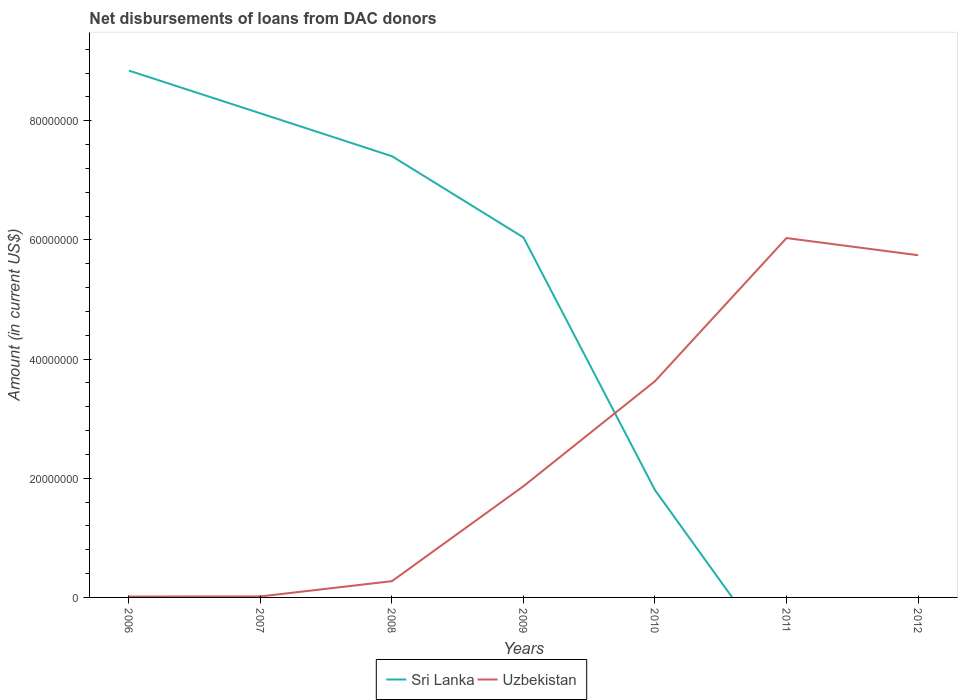Does the line corresponding to Uzbekistan intersect with the line corresponding to Sri Lanka?
Provide a short and direct response. Yes. Is the number of lines equal to the number of legend labels?
Provide a succinct answer. No. Across all years, what is the maximum amount of loans disbursed in Sri Lanka?
Your response must be concise. 0. What is the total amount of loans disbursed in Uzbekistan in the graph?
Ensure brevity in your answer.  -1.59e+07. What is the difference between the highest and the second highest amount of loans disbursed in Uzbekistan?
Provide a short and direct response. 6.02e+07. What is the difference between two consecutive major ticks on the Y-axis?
Make the answer very short. 2.00e+07. Are the values on the major ticks of Y-axis written in scientific E-notation?
Keep it short and to the point. No. Does the graph contain any zero values?
Give a very brief answer. Yes. Does the graph contain grids?
Your answer should be very brief. No. How many legend labels are there?
Offer a terse response. 2. What is the title of the graph?
Your answer should be very brief. Net disbursements of loans from DAC donors. Does "Malawi" appear as one of the legend labels in the graph?
Give a very brief answer. No. What is the label or title of the X-axis?
Ensure brevity in your answer.  Years. What is the Amount (in current US$) of Sri Lanka in 2006?
Give a very brief answer. 8.84e+07. What is the Amount (in current US$) of Uzbekistan in 2006?
Keep it short and to the point. 1.50e+05. What is the Amount (in current US$) in Sri Lanka in 2007?
Provide a succinct answer. 8.13e+07. What is the Amount (in current US$) in Uzbekistan in 2007?
Your answer should be very brief. 1.67e+05. What is the Amount (in current US$) of Sri Lanka in 2008?
Offer a very short reply. 7.41e+07. What is the Amount (in current US$) of Uzbekistan in 2008?
Give a very brief answer. 2.73e+06. What is the Amount (in current US$) of Sri Lanka in 2009?
Offer a terse response. 6.04e+07. What is the Amount (in current US$) of Uzbekistan in 2009?
Make the answer very short. 1.87e+07. What is the Amount (in current US$) in Sri Lanka in 2010?
Make the answer very short. 1.80e+07. What is the Amount (in current US$) of Uzbekistan in 2010?
Offer a terse response. 3.63e+07. What is the Amount (in current US$) of Sri Lanka in 2011?
Offer a terse response. 0. What is the Amount (in current US$) in Uzbekistan in 2011?
Offer a very short reply. 6.03e+07. What is the Amount (in current US$) of Sri Lanka in 2012?
Keep it short and to the point. 0. What is the Amount (in current US$) of Uzbekistan in 2012?
Give a very brief answer. 5.74e+07. Across all years, what is the maximum Amount (in current US$) in Sri Lanka?
Your response must be concise. 8.84e+07. Across all years, what is the maximum Amount (in current US$) in Uzbekistan?
Provide a succinct answer. 6.03e+07. Across all years, what is the minimum Amount (in current US$) in Sri Lanka?
Make the answer very short. 0. What is the total Amount (in current US$) of Sri Lanka in the graph?
Make the answer very short. 3.22e+08. What is the total Amount (in current US$) in Uzbekistan in the graph?
Provide a succinct answer. 1.76e+08. What is the difference between the Amount (in current US$) of Sri Lanka in 2006 and that in 2007?
Offer a terse response. 7.17e+06. What is the difference between the Amount (in current US$) of Uzbekistan in 2006 and that in 2007?
Your answer should be very brief. -1.70e+04. What is the difference between the Amount (in current US$) of Sri Lanka in 2006 and that in 2008?
Provide a succinct answer. 1.44e+07. What is the difference between the Amount (in current US$) of Uzbekistan in 2006 and that in 2008?
Keep it short and to the point. -2.58e+06. What is the difference between the Amount (in current US$) in Sri Lanka in 2006 and that in 2009?
Offer a terse response. 2.80e+07. What is the difference between the Amount (in current US$) of Uzbekistan in 2006 and that in 2009?
Provide a short and direct response. -1.85e+07. What is the difference between the Amount (in current US$) of Sri Lanka in 2006 and that in 2010?
Ensure brevity in your answer.  7.04e+07. What is the difference between the Amount (in current US$) in Uzbekistan in 2006 and that in 2010?
Give a very brief answer. -3.61e+07. What is the difference between the Amount (in current US$) of Uzbekistan in 2006 and that in 2011?
Provide a succinct answer. -6.02e+07. What is the difference between the Amount (in current US$) in Uzbekistan in 2006 and that in 2012?
Your response must be concise. -5.73e+07. What is the difference between the Amount (in current US$) of Sri Lanka in 2007 and that in 2008?
Keep it short and to the point. 7.20e+06. What is the difference between the Amount (in current US$) in Uzbekistan in 2007 and that in 2008?
Your answer should be compact. -2.56e+06. What is the difference between the Amount (in current US$) in Sri Lanka in 2007 and that in 2009?
Provide a succinct answer. 2.08e+07. What is the difference between the Amount (in current US$) in Uzbekistan in 2007 and that in 2009?
Make the answer very short. -1.85e+07. What is the difference between the Amount (in current US$) of Sri Lanka in 2007 and that in 2010?
Provide a short and direct response. 6.32e+07. What is the difference between the Amount (in current US$) in Uzbekistan in 2007 and that in 2010?
Your response must be concise. -3.61e+07. What is the difference between the Amount (in current US$) in Uzbekistan in 2007 and that in 2011?
Offer a very short reply. -6.02e+07. What is the difference between the Amount (in current US$) in Uzbekistan in 2007 and that in 2012?
Provide a short and direct response. -5.73e+07. What is the difference between the Amount (in current US$) of Sri Lanka in 2008 and that in 2009?
Provide a short and direct response. 1.36e+07. What is the difference between the Amount (in current US$) of Uzbekistan in 2008 and that in 2009?
Offer a very short reply. -1.59e+07. What is the difference between the Amount (in current US$) of Sri Lanka in 2008 and that in 2010?
Make the answer very short. 5.60e+07. What is the difference between the Amount (in current US$) of Uzbekistan in 2008 and that in 2010?
Your answer should be very brief. -3.36e+07. What is the difference between the Amount (in current US$) in Uzbekistan in 2008 and that in 2011?
Give a very brief answer. -5.76e+07. What is the difference between the Amount (in current US$) of Uzbekistan in 2008 and that in 2012?
Provide a short and direct response. -5.47e+07. What is the difference between the Amount (in current US$) of Sri Lanka in 2009 and that in 2010?
Make the answer very short. 4.24e+07. What is the difference between the Amount (in current US$) of Uzbekistan in 2009 and that in 2010?
Your answer should be very brief. -1.76e+07. What is the difference between the Amount (in current US$) of Uzbekistan in 2009 and that in 2011?
Offer a very short reply. -4.16e+07. What is the difference between the Amount (in current US$) in Uzbekistan in 2009 and that in 2012?
Ensure brevity in your answer.  -3.88e+07. What is the difference between the Amount (in current US$) of Uzbekistan in 2010 and that in 2011?
Provide a succinct answer. -2.40e+07. What is the difference between the Amount (in current US$) of Uzbekistan in 2010 and that in 2012?
Your answer should be very brief. -2.11e+07. What is the difference between the Amount (in current US$) of Uzbekistan in 2011 and that in 2012?
Make the answer very short. 2.88e+06. What is the difference between the Amount (in current US$) of Sri Lanka in 2006 and the Amount (in current US$) of Uzbekistan in 2007?
Your answer should be very brief. 8.83e+07. What is the difference between the Amount (in current US$) of Sri Lanka in 2006 and the Amount (in current US$) of Uzbekistan in 2008?
Keep it short and to the point. 8.57e+07. What is the difference between the Amount (in current US$) of Sri Lanka in 2006 and the Amount (in current US$) of Uzbekistan in 2009?
Provide a short and direct response. 6.98e+07. What is the difference between the Amount (in current US$) of Sri Lanka in 2006 and the Amount (in current US$) of Uzbekistan in 2010?
Your answer should be compact. 5.21e+07. What is the difference between the Amount (in current US$) in Sri Lanka in 2006 and the Amount (in current US$) in Uzbekistan in 2011?
Your answer should be compact. 2.81e+07. What is the difference between the Amount (in current US$) in Sri Lanka in 2006 and the Amount (in current US$) in Uzbekistan in 2012?
Your answer should be compact. 3.10e+07. What is the difference between the Amount (in current US$) in Sri Lanka in 2007 and the Amount (in current US$) in Uzbekistan in 2008?
Provide a succinct answer. 7.85e+07. What is the difference between the Amount (in current US$) in Sri Lanka in 2007 and the Amount (in current US$) in Uzbekistan in 2009?
Your answer should be very brief. 6.26e+07. What is the difference between the Amount (in current US$) in Sri Lanka in 2007 and the Amount (in current US$) in Uzbekistan in 2010?
Make the answer very short. 4.50e+07. What is the difference between the Amount (in current US$) of Sri Lanka in 2007 and the Amount (in current US$) of Uzbekistan in 2011?
Your response must be concise. 2.09e+07. What is the difference between the Amount (in current US$) of Sri Lanka in 2007 and the Amount (in current US$) of Uzbekistan in 2012?
Your answer should be compact. 2.38e+07. What is the difference between the Amount (in current US$) in Sri Lanka in 2008 and the Amount (in current US$) in Uzbekistan in 2009?
Give a very brief answer. 5.54e+07. What is the difference between the Amount (in current US$) in Sri Lanka in 2008 and the Amount (in current US$) in Uzbekistan in 2010?
Your answer should be compact. 3.78e+07. What is the difference between the Amount (in current US$) of Sri Lanka in 2008 and the Amount (in current US$) of Uzbekistan in 2011?
Make the answer very short. 1.37e+07. What is the difference between the Amount (in current US$) in Sri Lanka in 2008 and the Amount (in current US$) in Uzbekistan in 2012?
Make the answer very short. 1.66e+07. What is the difference between the Amount (in current US$) of Sri Lanka in 2009 and the Amount (in current US$) of Uzbekistan in 2010?
Ensure brevity in your answer.  2.41e+07. What is the difference between the Amount (in current US$) of Sri Lanka in 2009 and the Amount (in current US$) of Uzbekistan in 2011?
Your response must be concise. 1.03e+05. What is the difference between the Amount (in current US$) of Sri Lanka in 2009 and the Amount (in current US$) of Uzbekistan in 2012?
Your response must be concise. 2.98e+06. What is the difference between the Amount (in current US$) in Sri Lanka in 2010 and the Amount (in current US$) in Uzbekistan in 2011?
Offer a very short reply. -4.23e+07. What is the difference between the Amount (in current US$) in Sri Lanka in 2010 and the Amount (in current US$) in Uzbekistan in 2012?
Provide a succinct answer. -3.94e+07. What is the average Amount (in current US$) in Sri Lanka per year?
Offer a terse response. 4.60e+07. What is the average Amount (in current US$) of Uzbekistan per year?
Offer a very short reply. 2.51e+07. In the year 2006, what is the difference between the Amount (in current US$) in Sri Lanka and Amount (in current US$) in Uzbekistan?
Keep it short and to the point. 8.83e+07. In the year 2007, what is the difference between the Amount (in current US$) of Sri Lanka and Amount (in current US$) of Uzbekistan?
Keep it short and to the point. 8.11e+07. In the year 2008, what is the difference between the Amount (in current US$) of Sri Lanka and Amount (in current US$) of Uzbekistan?
Give a very brief answer. 7.13e+07. In the year 2009, what is the difference between the Amount (in current US$) of Sri Lanka and Amount (in current US$) of Uzbekistan?
Offer a terse response. 4.18e+07. In the year 2010, what is the difference between the Amount (in current US$) of Sri Lanka and Amount (in current US$) of Uzbekistan?
Your answer should be compact. -1.83e+07. What is the ratio of the Amount (in current US$) in Sri Lanka in 2006 to that in 2007?
Offer a terse response. 1.09. What is the ratio of the Amount (in current US$) in Uzbekistan in 2006 to that in 2007?
Your answer should be very brief. 0.9. What is the ratio of the Amount (in current US$) in Sri Lanka in 2006 to that in 2008?
Your answer should be very brief. 1.19. What is the ratio of the Amount (in current US$) of Uzbekistan in 2006 to that in 2008?
Your answer should be very brief. 0.05. What is the ratio of the Amount (in current US$) of Sri Lanka in 2006 to that in 2009?
Ensure brevity in your answer.  1.46. What is the ratio of the Amount (in current US$) of Uzbekistan in 2006 to that in 2009?
Your answer should be very brief. 0.01. What is the ratio of the Amount (in current US$) in Sri Lanka in 2006 to that in 2010?
Make the answer very short. 4.91. What is the ratio of the Amount (in current US$) in Uzbekistan in 2006 to that in 2010?
Offer a terse response. 0. What is the ratio of the Amount (in current US$) in Uzbekistan in 2006 to that in 2011?
Make the answer very short. 0. What is the ratio of the Amount (in current US$) in Uzbekistan in 2006 to that in 2012?
Your response must be concise. 0. What is the ratio of the Amount (in current US$) in Sri Lanka in 2007 to that in 2008?
Give a very brief answer. 1.1. What is the ratio of the Amount (in current US$) in Uzbekistan in 2007 to that in 2008?
Provide a succinct answer. 0.06. What is the ratio of the Amount (in current US$) in Sri Lanka in 2007 to that in 2009?
Your answer should be compact. 1.34. What is the ratio of the Amount (in current US$) of Uzbekistan in 2007 to that in 2009?
Offer a very short reply. 0.01. What is the ratio of the Amount (in current US$) of Sri Lanka in 2007 to that in 2010?
Provide a succinct answer. 4.51. What is the ratio of the Amount (in current US$) of Uzbekistan in 2007 to that in 2010?
Keep it short and to the point. 0. What is the ratio of the Amount (in current US$) of Uzbekistan in 2007 to that in 2011?
Your answer should be compact. 0. What is the ratio of the Amount (in current US$) in Uzbekistan in 2007 to that in 2012?
Your answer should be very brief. 0. What is the ratio of the Amount (in current US$) of Sri Lanka in 2008 to that in 2009?
Offer a terse response. 1.23. What is the ratio of the Amount (in current US$) in Uzbekistan in 2008 to that in 2009?
Your answer should be very brief. 0.15. What is the ratio of the Amount (in current US$) of Sri Lanka in 2008 to that in 2010?
Your answer should be very brief. 4.11. What is the ratio of the Amount (in current US$) of Uzbekistan in 2008 to that in 2010?
Your answer should be very brief. 0.08. What is the ratio of the Amount (in current US$) of Uzbekistan in 2008 to that in 2011?
Provide a short and direct response. 0.05. What is the ratio of the Amount (in current US$) in Uzbekistan in 2008 to that in 2012?
Keep it short and to the point. 0.05. What is the ratio of the Amount (in current US$) in Sri Lanka in 2009 to that in 2010?
Offer a terse response. 3.35. What is the ratio of the Amount (in current US$) of Uzbekistan in 2009 to that in 2010?
Keep it short and to the point. 0.51. What is the ratio of the Amount (in current US$) of Uzbekistan in 2009 to that in 2011?
Your response must be concise. 0.31. What is the ratio of the Amount (in current US$) of Uzbekistan in 2009 to that in 2012?
Your response must be concise. 0.33. What is the ratio of the Amount (in current US$) in Uzbekistan in 2010 to that in 2011?
Give a very brief answer. 0.6. What is the ratio of the Amount (in current US$) of Uzbekistan in 2010 to that in 2012?
Provide a short and direct response. 0.63. What is the ratio of the Amount (in current US$) in Uzbekistan in 2011 to that in 2012?
Make the answer very short. 1.05. What is the difference between the highest and the second highest Amount (in current US$) of Sri Lanka?
Your answer should be compact. 7.17e+06. What is the difference between the highest and the second highest Amount (in current US$) of Uzbekistan?
Provide a short and direct response. 2.88e+06. What is the difference between the highest and the lowest Amount (in current US$) of Sri Lanka?
Make the answer very short. 8.84e+07. What is the difference between the highest and the lowest Amount (in current US$) of Uzbekistan?
Your response must be concise. 6.02e+07. 